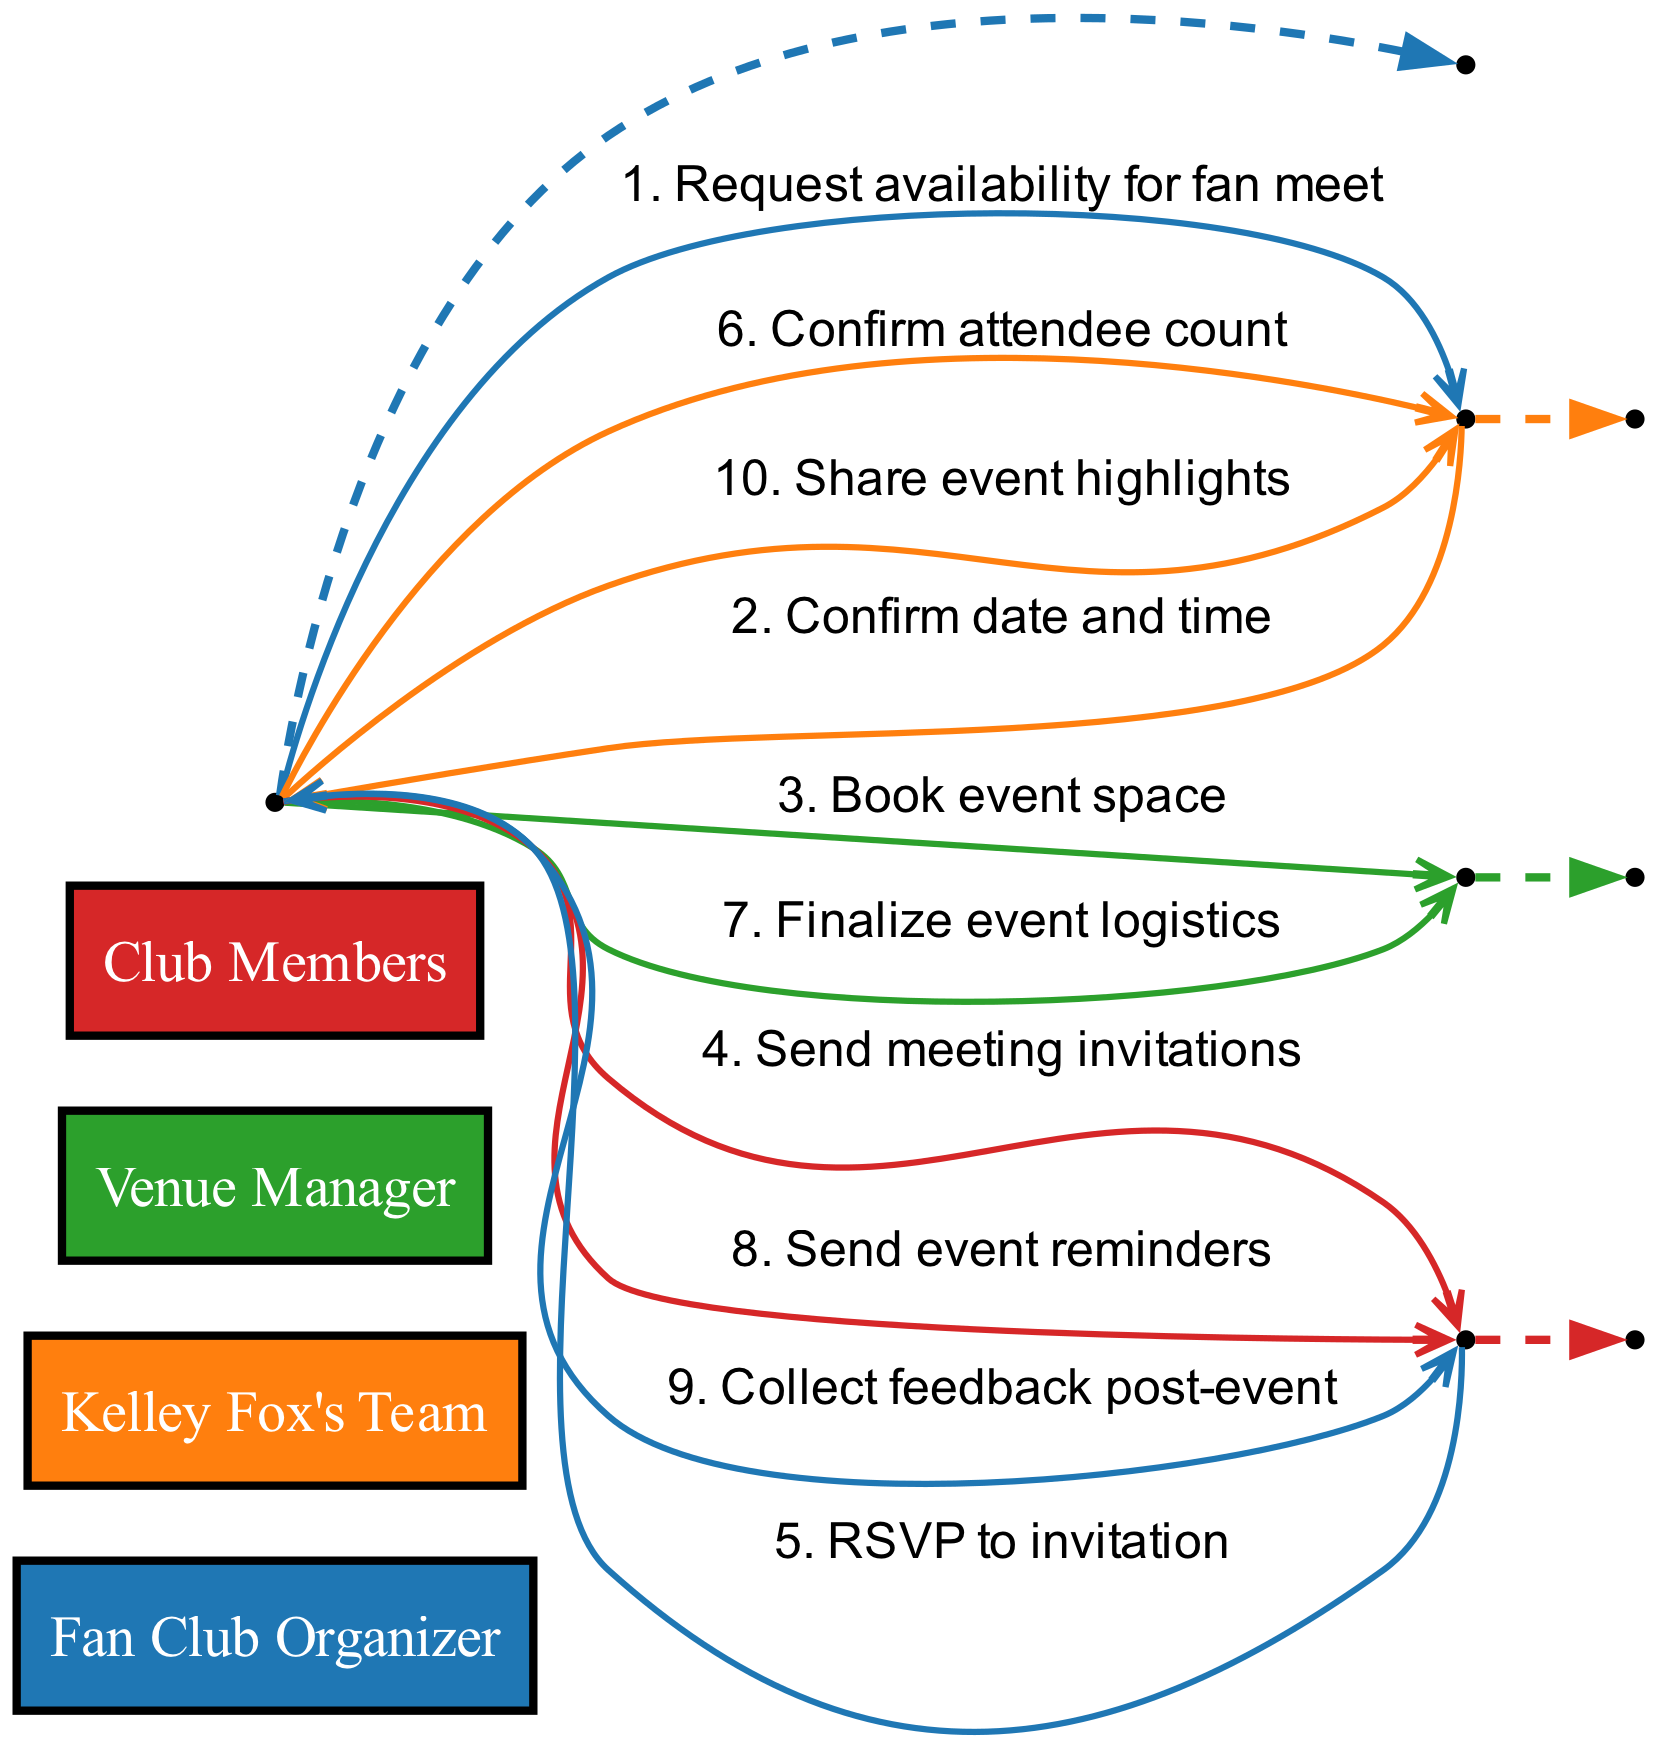What is the first message sent in the sequence? The first message in the sequence is sent from the Fan Club Organizer to Kelley Fox's Team, asking for the availability for a fan meet.
Answer: Request availability for fan meet How many actors are involved in this sequence? There are four actors involved in the sequence: Fan Club Organizer, Kelley Fox's Team, Venue Manager, and Club Members.
Answer: Four Which message confirms the date and time? The message that confirms the date and time is sent from Kelley Fox's Team to the Fan Club Organizer.
Answer: Confirm date and time What is the last action taken by the Fan Club Organizer? The last action taken by the Fan Club Organizer is sending event highlights to Kelley Fox's Team.
Answer: Share event highlights How many messages are exchanged between the Fan Club Organizer and Club Members? There are three messages exchanged between the Fan Club Organizer and Club Members in the sequence.
Answer: Three What role does the Venue Manager play in this process? The Venue Manager's role includes booking the event space and finalizing event logistics.
Answer: Book event space, Finalize event logistics Which message is sent after collecting feedback post-event? The message sent after collecting feedback is to share event highlights with Kelley Fox's Team.
Answer: Share event highlights How many RSVP responses does the Fan Club Organizer receive from Club Members? The Fan Club Organizer receives multiple RSVP responses from Club Members, as indicated in the flow.
Answer: Multiple In which step does the Fan Club Organizer finalize the attendee count? The Fan Club Organizer finalizes the attendee count after receiving RSVPs from Club Members.
Answer: Confirm attendee count 